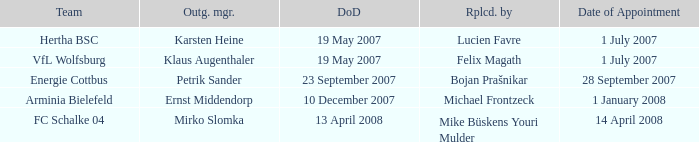When was the appointment date for the manager replaced by Lucien Favre? 1 July 2007. 